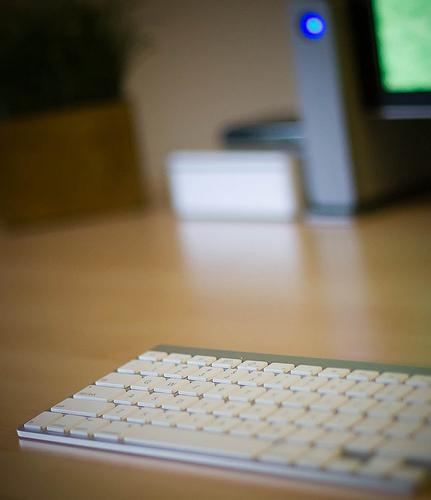Question: why is the light glowing?
Choices:
A. The hard drive is on.
B. To show there is power.
C. To warn the user.
D. To signal people.
Answer with the letter. Answer: A Question: what is on the wood?
Choices:
A. Books.
B. Computer equipment.
C. Newspapers.
D. Pens and pencils.
Answer with the letter. Answer: B Question: how is the keyboard laying?
Choices:
A. At an angle.
B. Hanging.
C. Behind the books.
D. Flat.
Answer with the letter. Answer: D 